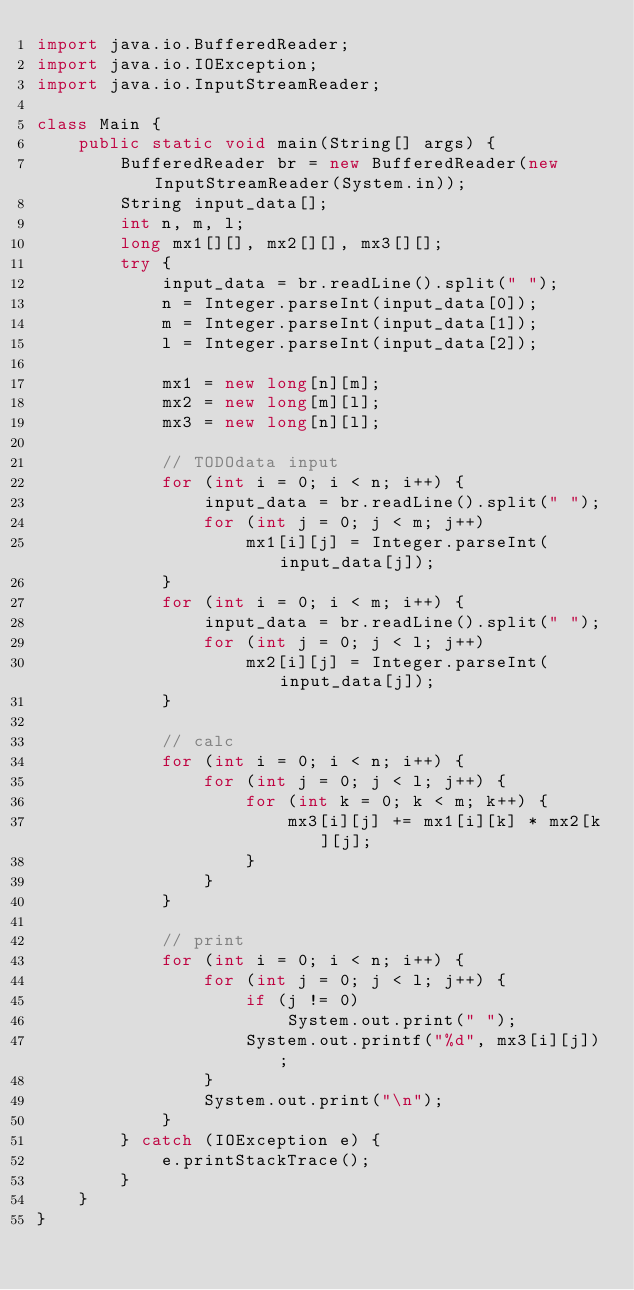Convert code to text. <code><loc_0><loc_0><loc_500><loc_500><_Java_>import java.io.BufferedReader;
import java.io.IOException;
import java.io.InputStreamReader;

class Main {
    public static void main(String[] args) {
        BufferedReader br = new BufferedReader(new InputStreamReader(System.in));
        String input_data[];
        int n, m, l;
        long mx1[][], mx2[][], mx3[][];
        try {
            input_data = br.readLine().split(" ");
            n = Integer.parseInt(input_data[0]);
            m = Integer.parseInt(input_data[1]);
            l = Integer.parseInt(input_data[2]);

            mx1 = new long[n][m];
            mx2 = new long[m][l];
            mx3 = new long[n][l];

            // TODOdata input
            for (int i = 0; i < n; i++) {
                input_data = br.readLine().split(" ");
                for (int j = 0; j < m; j++)
                    mx1[i][j] = Integer.parseInt(input_data[j]);
            }
            for (int i = 0; i < m; i++) {
                input_data = br.readLine().split(" ");
                for (int j = 0; j < l; j++)
                    mx2[i][j] = Integer.parseInt(input_data[j]);
            }

            // calc
            for (int i = 0; i < n; i++) {
                for (int j = 0; j < l; j++) {
                    for (int k = 0; k < m; k++) {
                        mx3[i][j] += mx1[i][k] * mx2[k][j];
                    }
                }
            }

            // print
            for (int i = 0; i < n; i++) {
                for (int j = 0; j < l; j++) {
                    if (j != 0)
                        System.out.print(" ");
                    System.out.printf("%d", mx3[i][j]);
                }
                System.out.print("\n");
            }
        } catch (IOException e) {
            e.printStackTrace();
        }
    }
}
</code> 